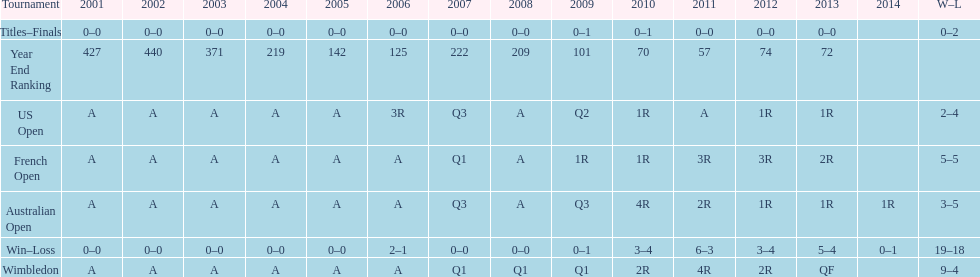Which tournament has the largest total win record? Wimbledon. 